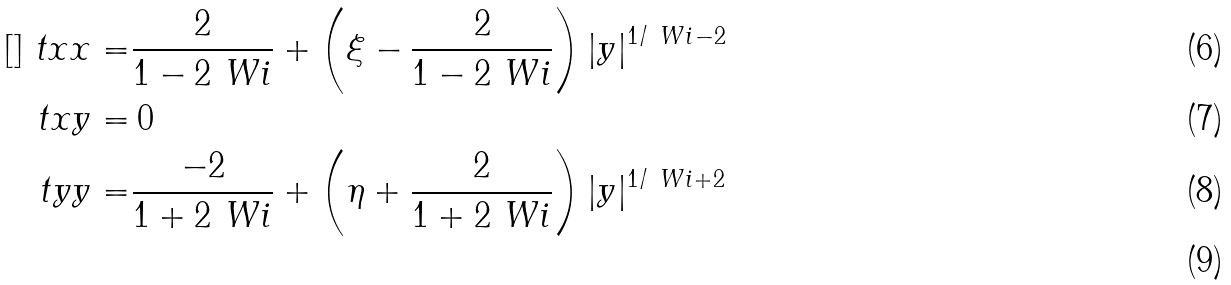<formula> <loc_0><loc_0><loc_500><loc_500>[ ] \ t x x = & \frac { 2 } { 1 - 2 \ W i } + \left ( \xi - \frac { 2 } { 1 - 2 \ W i } \right ) | y | ^ { 1 / \ W i - 2 } \\ \ t x y = & \, 0 \\ \ t y y = & \frac { - 2 } { 1 + 2 \ W i } + \left ( \eta + \frac { 2 } { 1 + 2 \ W i } \right ) | y | ^ { 1 / \ W i + 2 } \\</formula> 